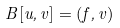Convert formula to latex. <formula><loc_0><loc_0><loc_500><loc_500>B [ u , v ] = ( f , v )</formula> 